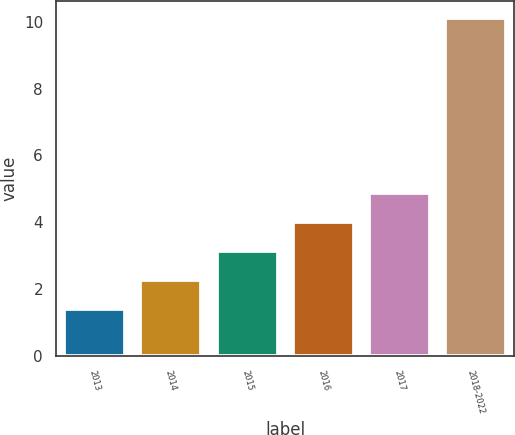Convert chart. <chart><loc_0><loc_0><loc_500><loc_500><bar_chart><fcel>2013<fcel>2014<fcel>2015<fcel>2016<fcel>2017<fcel>2018-2022<nl><fcel>1.4<fcel>2.27<fcel>3.14<fcel>4.01<fcel>4.88<fcel>10.1<nl></chart> 